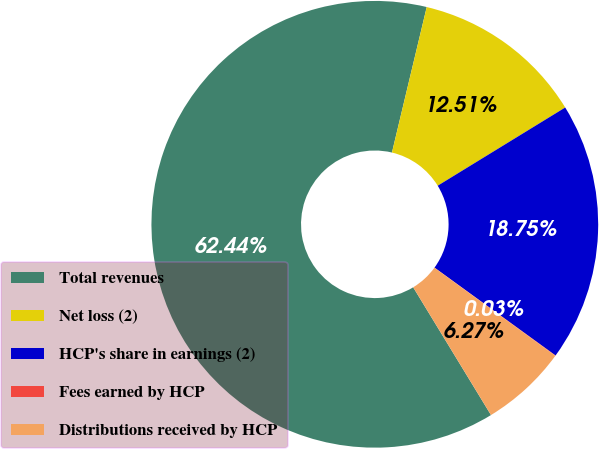<chart> <loc_0><loc_0><loc_500><loc_500><pie_chart><fcel>Total revenues<fcel>Net loss (2)<fcel>HCP's share in earnings (2)<fcel>Fees earned by HCP<fcel>Distributions received by HCP<nl><fcel>62.44%<fcel>12.51%<fcel>18.75%<fcel>0.03%<fcel>6.27%<nl></chart> 